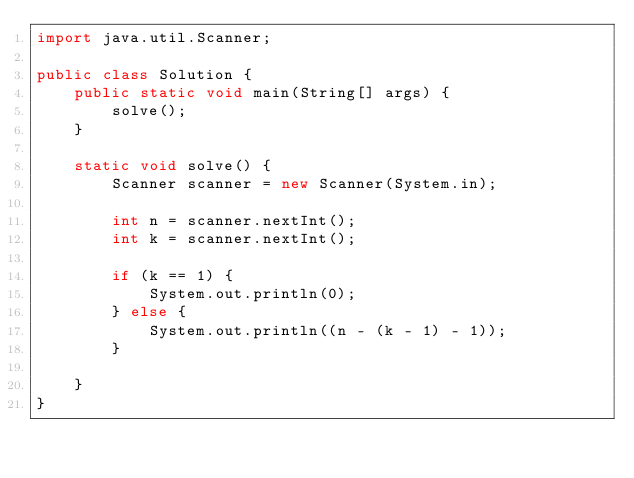<code> <loc_0><loc_0><loc_500><loc_500><_Java_>import java.util.Scanner;

public class Solution {
    public static void main(String[] args) {
        solve();
    }

    static void solve() {
        Scanner scanner = new Scanner(System.in);

        int n = scanner.nextInt();
        int k = scanner.nextInt();

        if (k == 1) {
            System.out.println(0);
        } else {
            System.out.println((n - (k - 1) - 1));
        }

    }
}
</code> 